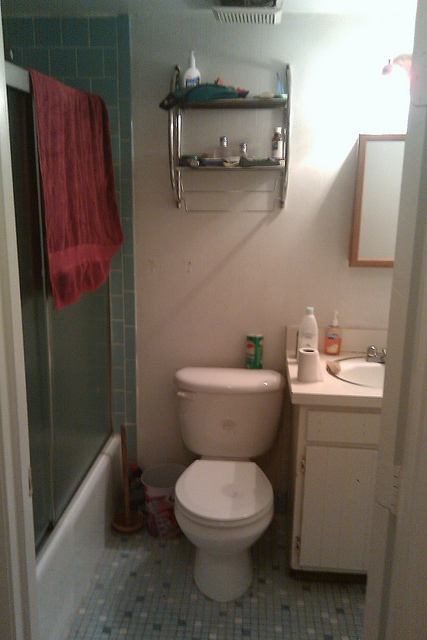What other cleaning supplies can you spot in the bathroom? In addition to the container on the toilet tank which likely holds a cleanser, there are other cleaning supplies visible in the bathroom. The toilet brush in its holder beside the toilet is an essential tool for maintaining toilet cleanliness. Additionally, the shelves above the toilet might contain products such as disinfectant sprays, wipes, or other cleaning agents commonly found in bathrooms. 